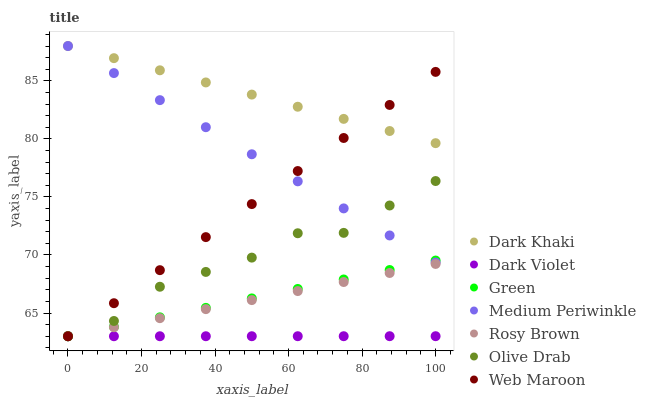Does Dark Violet have the minimum area under the curve?
Answer yes or no. Yes. Does Dark Khaki have the maximum area under the curve?
Answer yes or no. Yes. Does Rosy Brown have the minimum area under the curve?
Answer yes or no. No. Does Rosy Brown have the maximum area under the curve?
Answer yes or no. No. Is Rosy Brown the smoothest?
Answer yes or no. Yes. Is Olive Drab the roughest?
Answer yes or no. Yes. Is Medium Periwinkle the smoothest?
Answer yes or no. No. Is Medium Periwinkle the roughest?
Answer yes or no. No. Does Web Maroon have the lowest value?
Answer yes or no. Yes. Does Medium Periwinkle have the lowest value?
Answer yes or no. No. Does Dark Khaki have the highest value?
Answer yes or no. Yes. Does Rosy Brown have the highest value?
Answer yes or no. No. Is Dark Violet less than Dark Khaki?
Answer yes or no. Yes. Is Dark Khaki greater than Olive Drab?
Answer yes or no. Yes. Does Web Maroon intersect Olive Drab?
Answer yes or no. Yes. Is Web Maroon less than Olive Drab?
Answer yes or no. No. Is Web Maroon greater than Olive Drab?
Answer yes or no. No. Does Dark Violet intersect Dark Khaki?
Answer yes or no. No. 